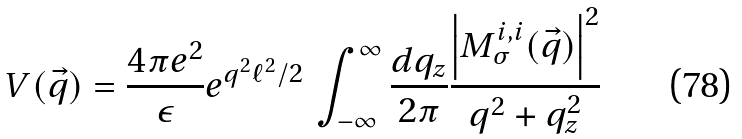<formula> <loc_0><loc_0><loc_500><loc_500>V ( \vec { q } ) = \frac { 4 \pi e ^ { 2 } } { \epsilon } e ^ { q ^ { 2 } \ell ^ { 2 } / 2 } \, \int _ { - \infty } ^ { \infty } \frac { d q _ { z } } { 2 \pi } \frac { \left | M _ { \sigma } ^ { i , i } ( \vec { q } ) \right | ^ { 2 } } { q ^ { 2 } + q _ { z } ^ { 2 } }</formula> 